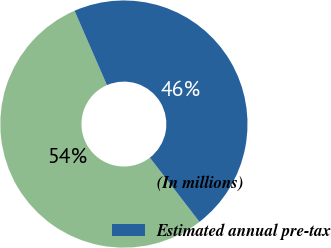Convert chart. <chart><loc_0><loc_0><loc_500><loc_500><pie_chart><fcel>(In millions)<fcel>Estimated annual pre-tax<nl><fcel>53.93%<fcel>46.07%<nl></chart> 